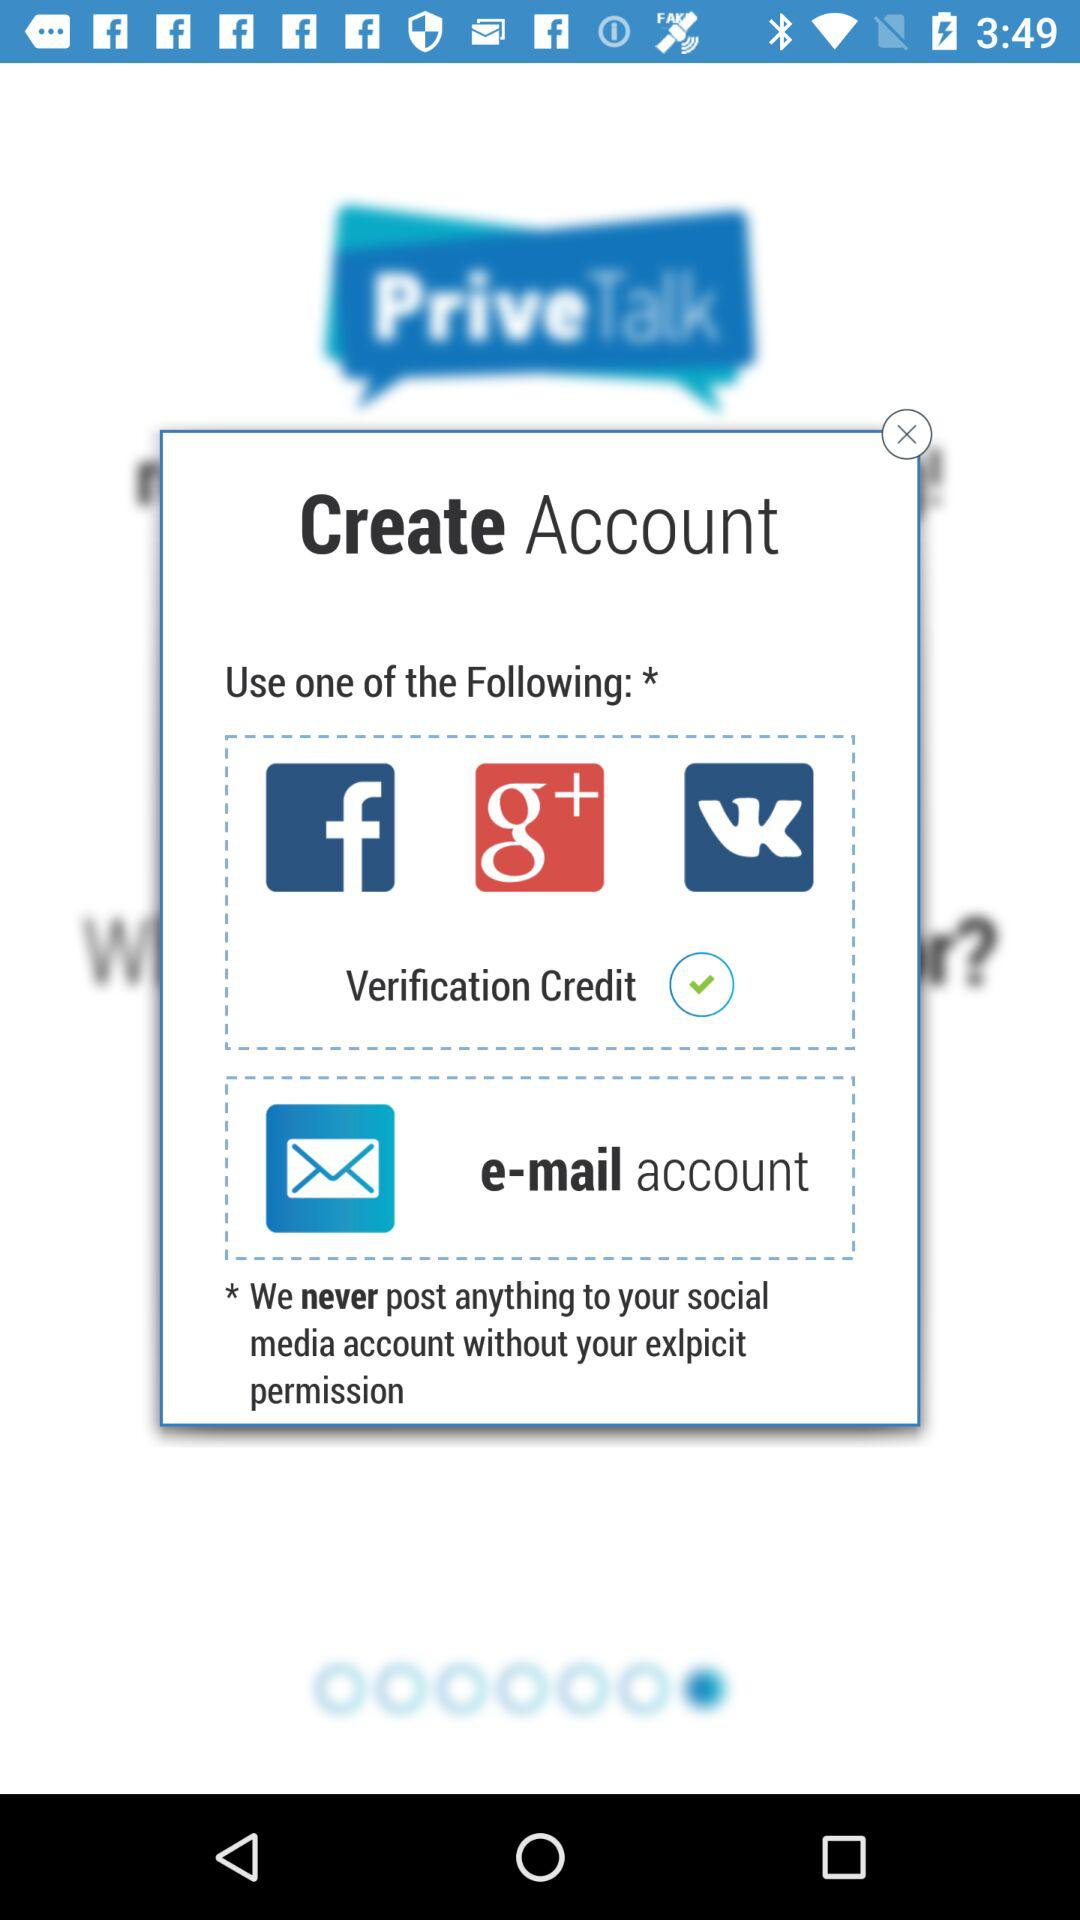How many verification credits are required to create an account?
Answer the question using a single word or phrase. 1 